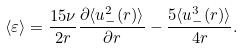Convert formula to latex. <formula><loc_0><loc_0><loc_500><loc_500>\langle \varepsilon \rangle = \frac { 1 5 \nu } { 2 r } \frac { \partial \langle u _ { - } ^ { 2 } ( r ) \rangle } { \partial r } - \frac { 5 \langle u _ { - } ^ { 3 } ( r ) \rangle } { 4 r } .</formula> 